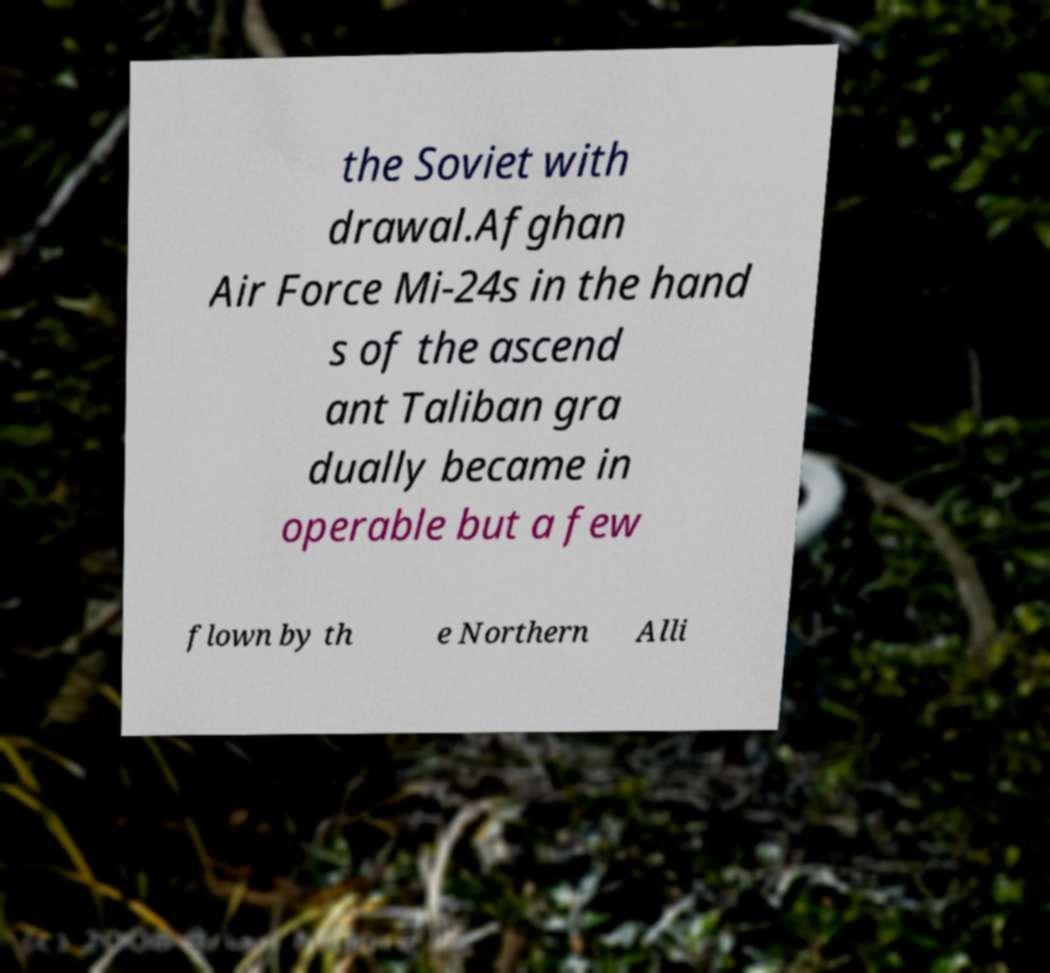What messages or text are displayed in this image? I need them in a readable, typed format. the Soviet with drawal.Afghan Air Force Mi-24s in the hand s of the ascend ant Taliban gra dually became in operable but a few flown by th e Northern Alli 